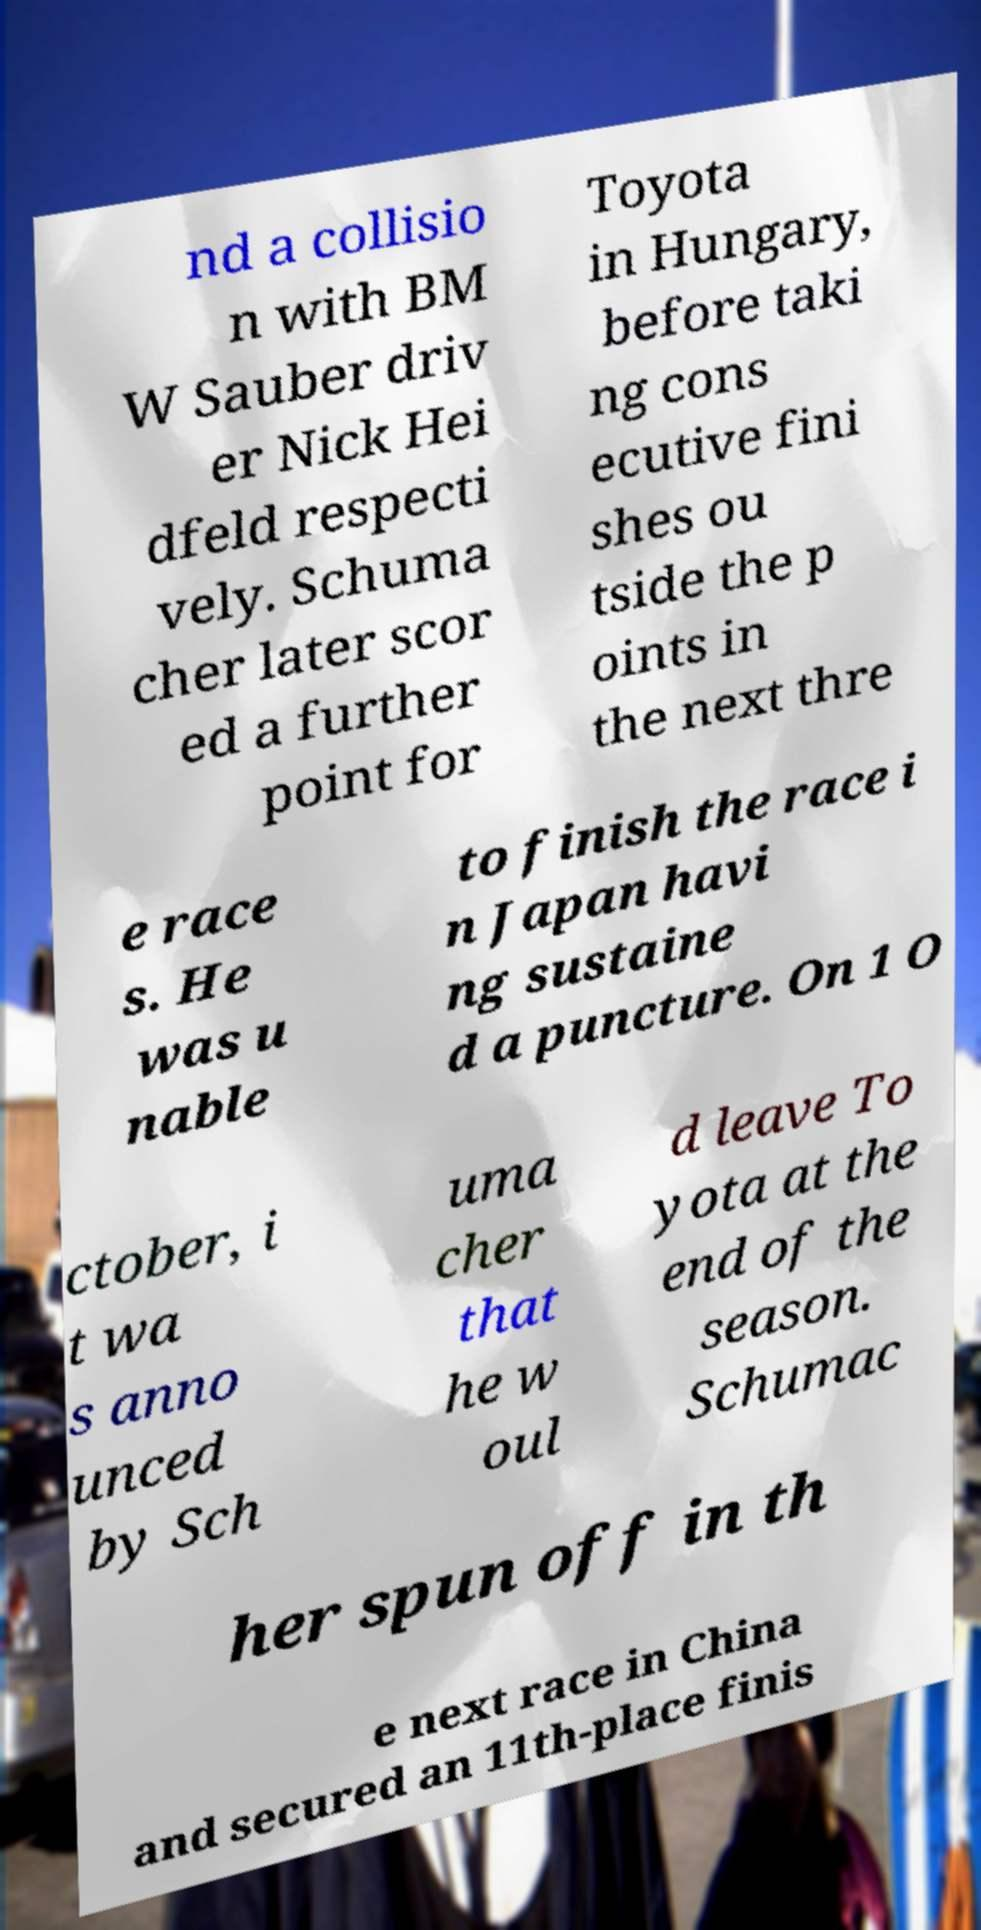There's text embedded in this image that I need extracted. Can you transcribe it verbatim? nd a collisio n with BM W Sauber driv er Nick Hei dfeld respecti vely. Schuma cher later scor ed a further point for Toyota in Hungary, before taki ng cons ecutive fini shes ou tside the p oints in the next thre e race s. He was u nable to finish the race i n Japan havi ng sustaine d a puncture. On 1 O ctober, i t wa s anno unced by Sch uma cher that he w oul d leave To yota at the end of the season. Schumac her spun off in th e next race in China and secured an 11th-place finis 